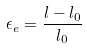Convert formula to latex. <formula><loc_0><loc_0><loc_500><loc_500>\epsilon _ { e } = \frac { l - l _ { 0 } } { l _ { 0 } }</formula> 